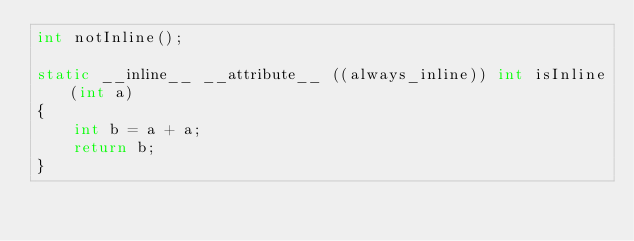Convert code to text. <code><loc_0><loc_0><loc_500><loc_500><_C_>int notInline();

static __inline__ __attribute__ ((always_inline)) int isInline(int a)
{
    int b = a + a;
    return b;
}
</code> 